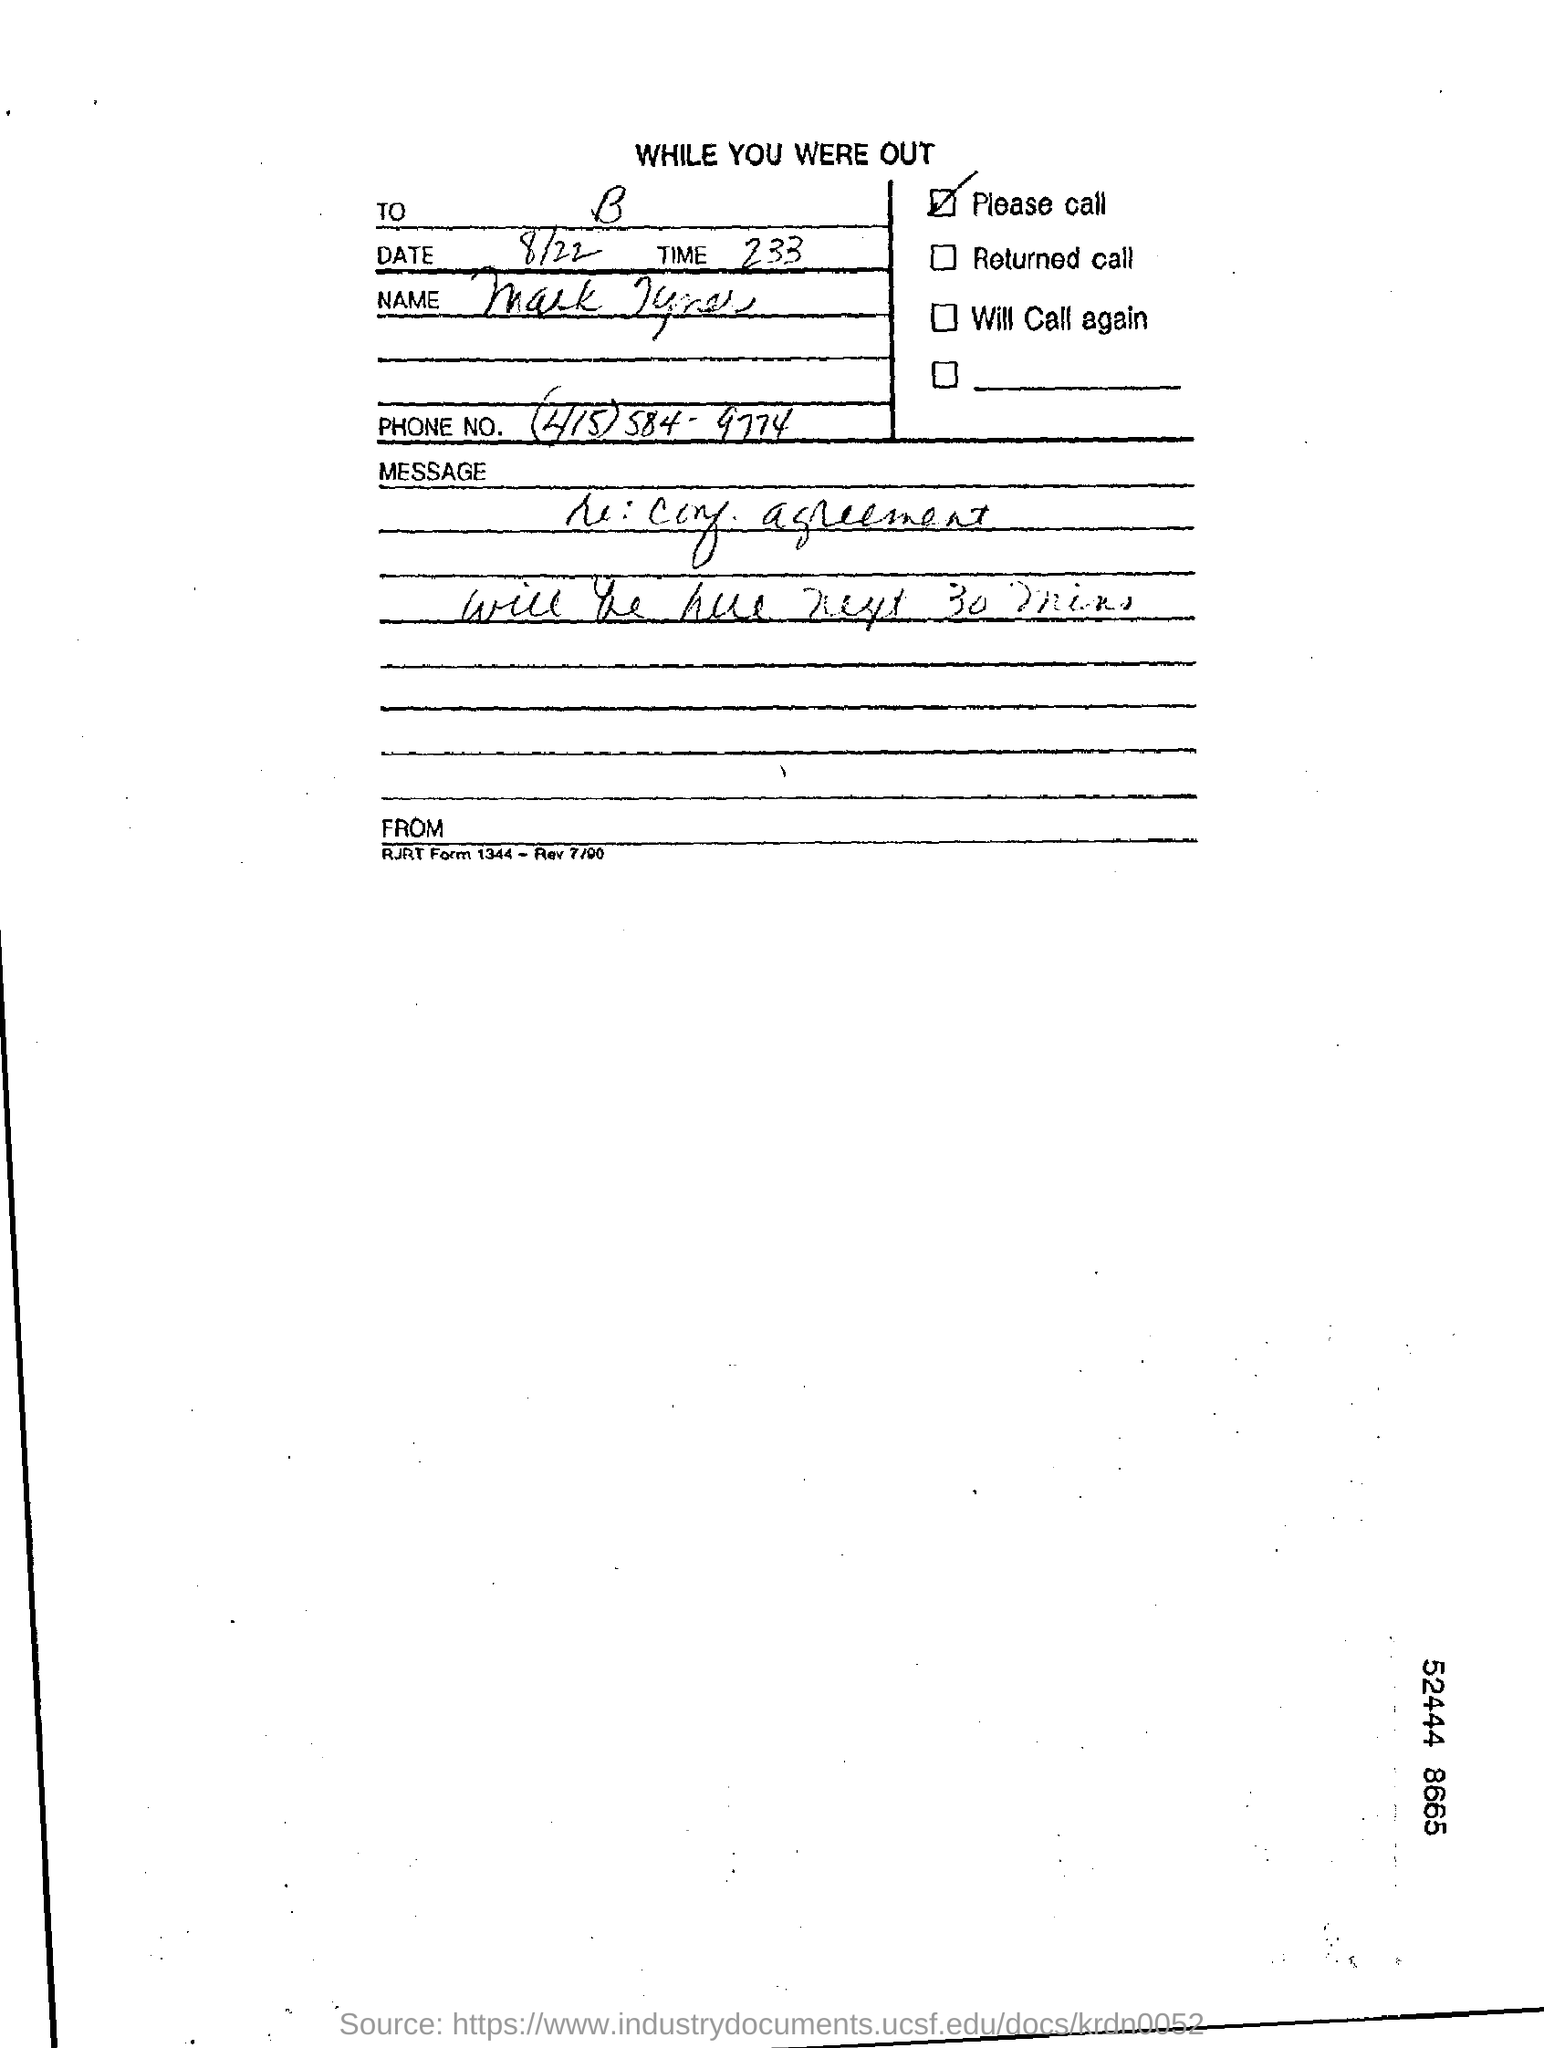What is the Date?
Give a very brief answer. 8/22. 